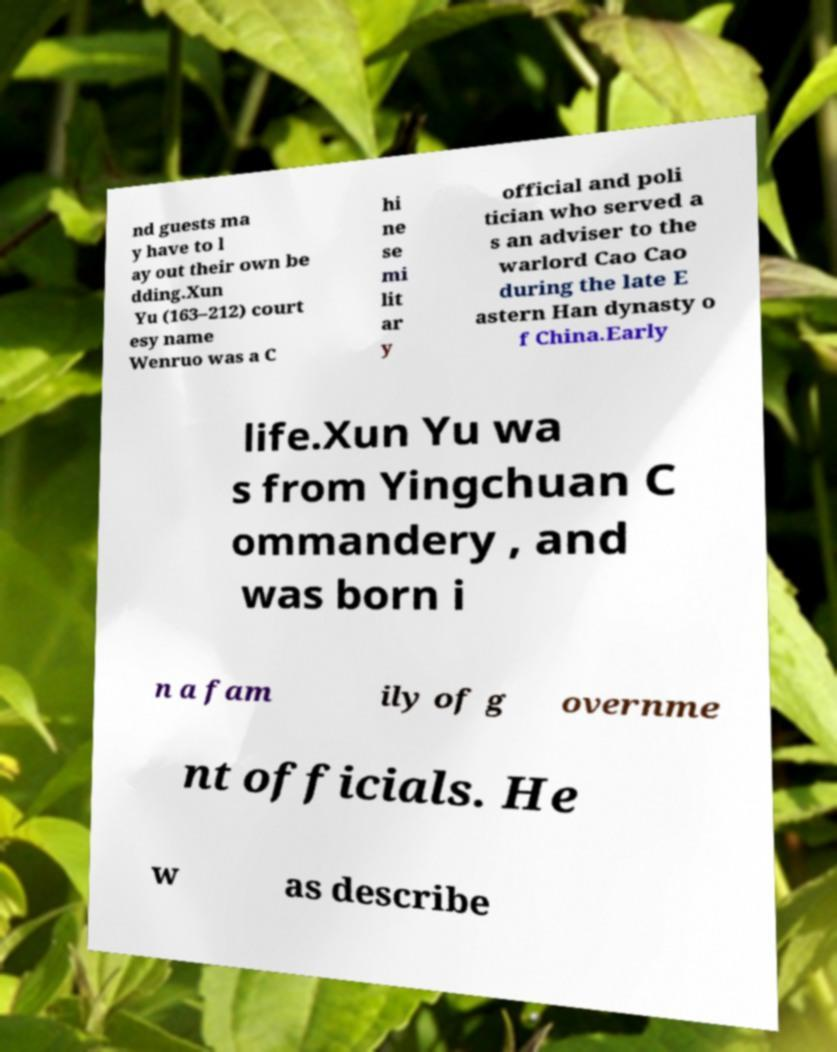There's text embedded in this image that I need extracted. Can you transcribe it verbatim? nd guests ma y have to l ay out their own be dding.Xun Yu (163–212) court esy name Wenruo was a C hi ne se mi lit ar y official and poli tician who served a s an adviser to the warlord Cao Cao during the late E astern Han dynasty o f China.Early life.Xun Yu wa s from Yingchuan C ommandery , and was born i n a fam ily of g overnme nt officials. He w as describe 